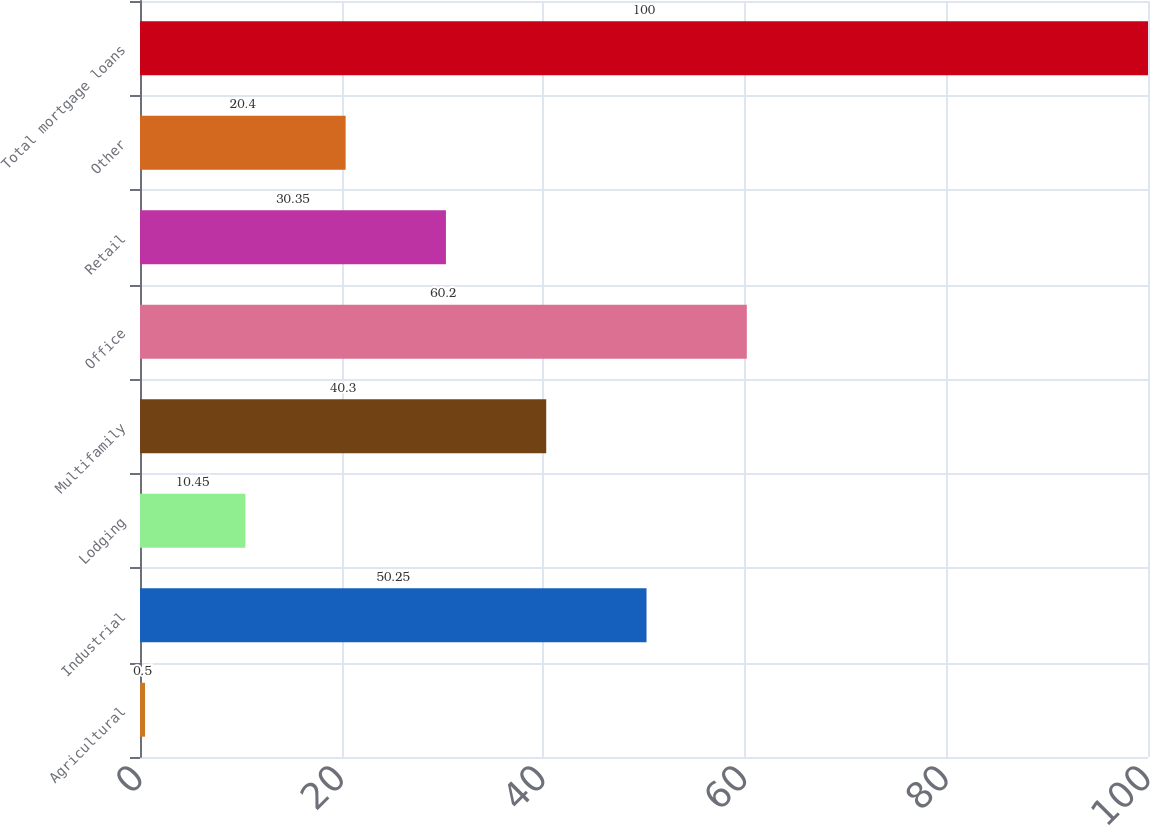Convert chart to OTSL. <chart><loc_0><loc_0><loc_500><loc_500><bar_chart><fcel>Agricultural<fcel>Industrial<fcel>Lodging<fcel>Multifamily<fcel>Office<fcel>Retail<fcel>Other<fcel>Total mortgage loans<nl><fcel>0.5<fcel>50.25<fcel>10.45<fcel>40.3<fcel>60.2<fcel>30.35<fcel>20.4<fcel>100<nl></chart> 